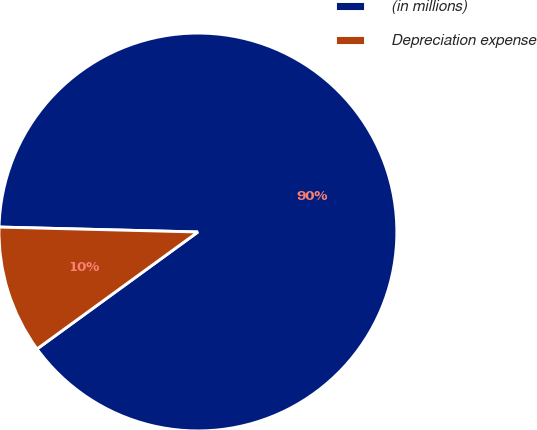Convert chart. <chart><loc_0><loc_0><loc_500><loc_500><pie_chart><fcel>(in millions)<fcel>Depreciation expense<nl><fcel>89.6%<fcel>10.4%<nl></chart> 